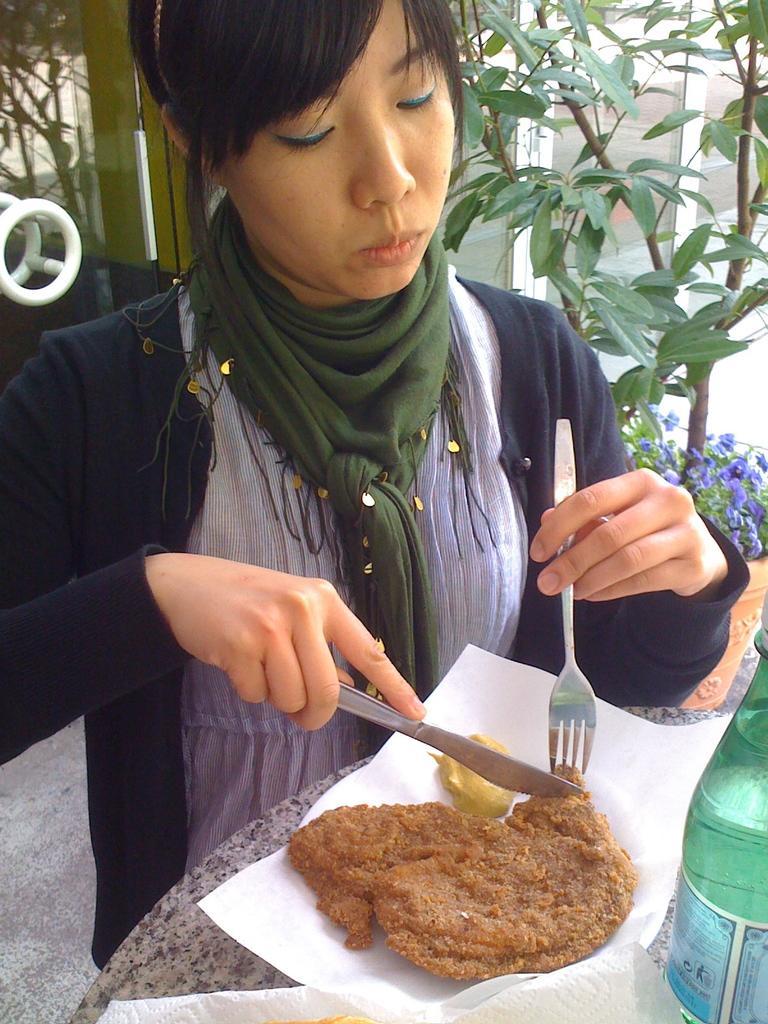Describe this image in one or two sentences. In this picture we can see a woman, she is holding a fork and a knife, in front of her we can see food, napkins and a bottle on the table, in the background we can see few plants and flowers. 